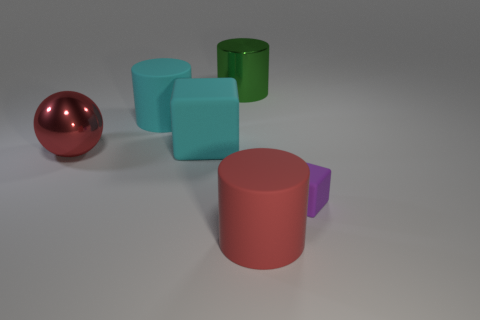There is a red cylinder that is the same size as the red metallic ball; what material is it?
Your response must be concise. Rubber. How many large objects are either red rubber cylinders or metal spheres?
Provide a succinct answer. 2. Are there any red rubber cylinders?
Provide a short and direct response. Yes. There is a green cylinder that is made of the same material as the large ball; what is its size?
Offer a terse response. Large. Does the red sphere have the same material as the large block?
Give a very brief answer. No. What number of other objects are the same material as the green cylinder?
Ensure brevity in your answer.  1. What number of large cylinders are behind the red cylinder and in front of the green cylinder?
Ensure brevity in your answer.  1. The large shiny sphere has what color?
Your response must be concise. Red. What material is the large object that is the same shape as the tiny purple rubber object?
Provide a succinct answer. Rubber. Are there any other things that are made of the same material as the purple object?
Your answer should be compact. Yes. 